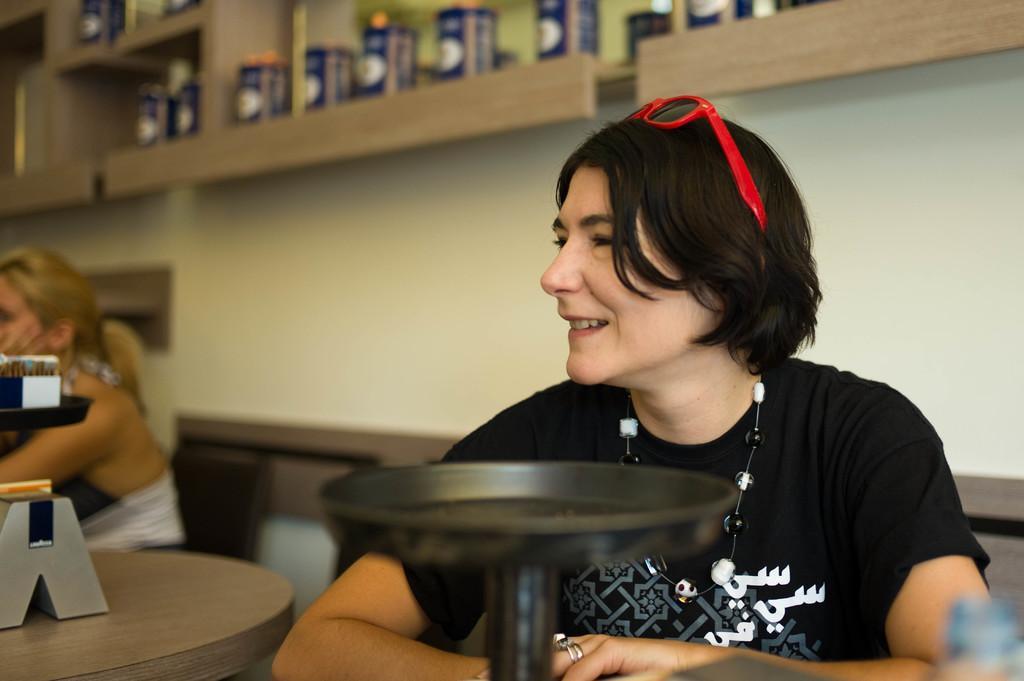Describe this image in one or two sentences. Here we can see a woman sitting and smiling, having goggles on her head and something present in front of her 